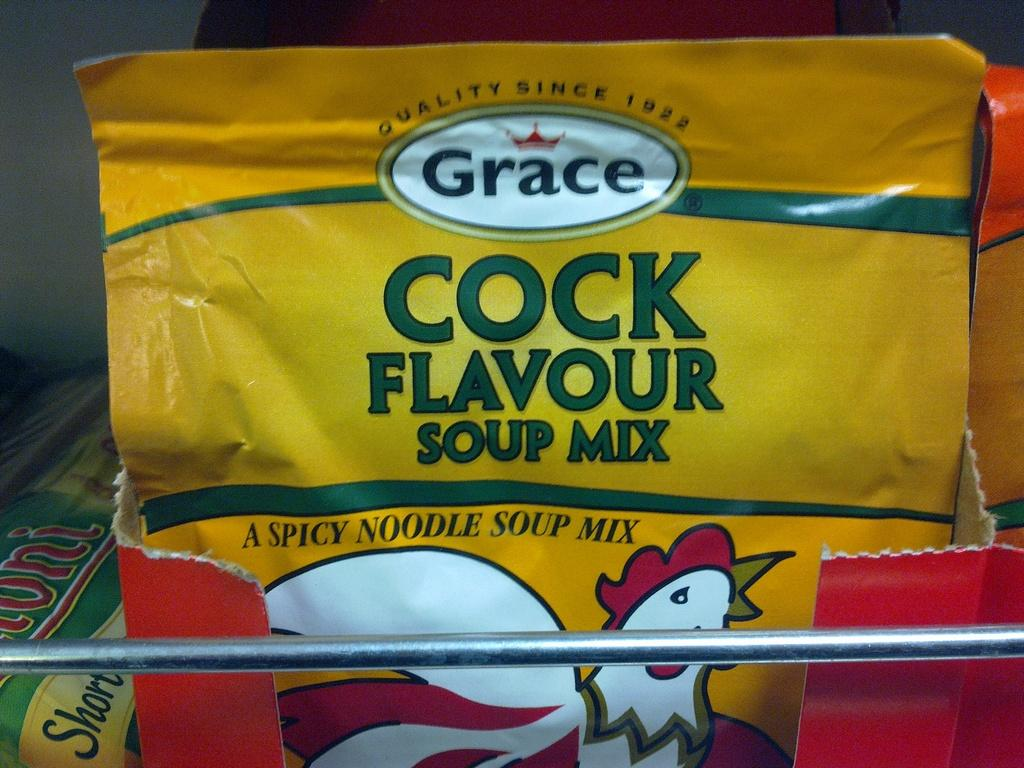What is the main object in the image? There is a soup packet in the image. Where is the soup packet located? The soup packet is in a box. What other object can be seen at the bottom of the image? There is an iron rod at the bottom of the image. What type of art is displayed on the soup packet? There is no art displayed on the soup packet in the image. What color are the trousers worn by the person holding the soup packet? There is no person holding the soup packet in the image, so we cannot determine the color of their trousers. 